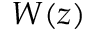Convert formula to latex. <formula><loc_0><loc_0><loc_500><loc_500>W ( z )</formula> 